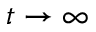<formula> <loc_0><loc_0><loc_500><loc_500>t \to \infty</formula> 